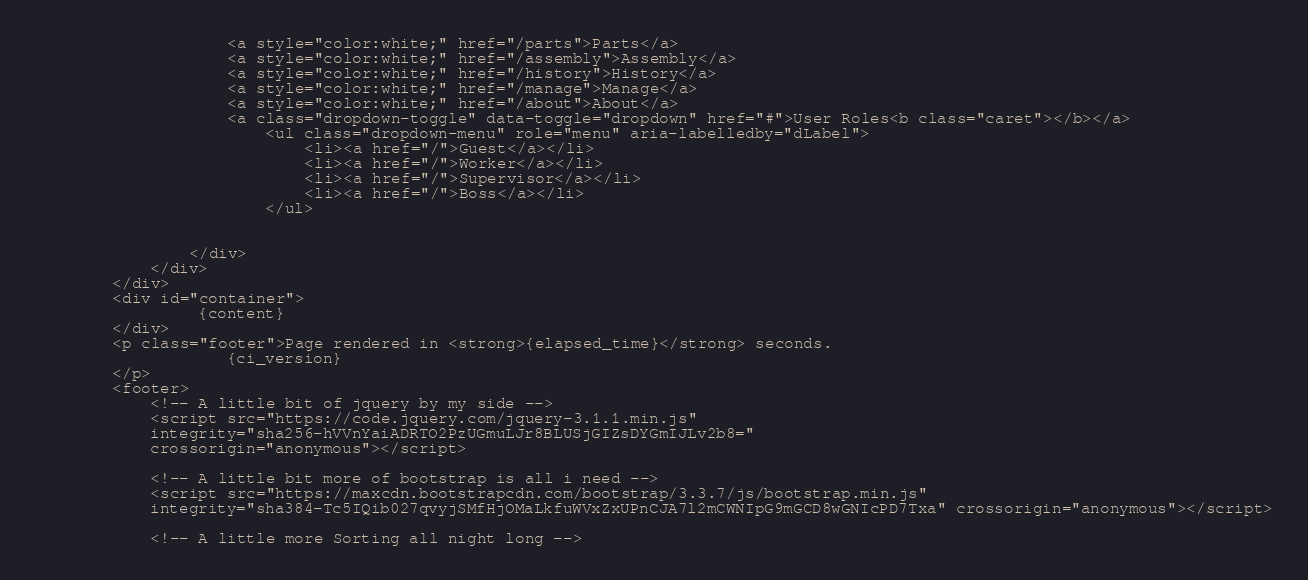<code> <loc_0><loc_0><loc_500><loc_500><_PHP_>					<a style="color:white;" href="/parts">Parts</a>
					<a style="color:white;" href="/assembly">Assembly</a>
					<a style="color:white;" href="/history">History</a>					
					<a style="color:white;" href="/manage">Manage</a>
					<a style="color:white;" href="/about">About</a> 
					<a class="dropdown-toggle" data-toggle="dropdown" href="#">User Roles<b class="caret"></b></a>
						<ul class="dropdown-menu" role="menu" aria-labelledby="dLabel">
							<li><a href="/">Guest</a></li>
							<li><a href="/">Worker</a></li>
							<li><a href="/">Supervisor</a></li>
							<li><a href="/">Boss</a></li>
						</ul>
					

				</div>
            </div>    
		</div>
		<div id="container">
				 {content}
		</div>  
		<p class="footer">Page rendered in <strong>{elapsed_time}</strong> seconds. 
					{ci_version}
		</p>     
		<footer>
			<!-- A little bit of jquery by my side --> 
			<script src="https://code.jquery.com/jquery-3.1.1.min.js" 
			integrity="sha256-hVVnYaiADRTO2PzUGmuLJr8BLUSjGIZsDYGmIJLv2b8="
			crossorigin="anonymous"></script>

			<!-- A little bit more of bootstrap is all i need -->
			<script src="https://maxcdn.bootstrapcdn.com/bootstrap/3.3.7/js/bootstrap.min.js" 
			integrity="sha384-Tc5IQib027qvyjSMfHjOMaLkfuWVxZxUPnCJA7l2mCWNIpG9mGCD8wGNIcPD7Txa" crossorigin="anonymous"></script>

			<!-- A little more Sorting all night long --> </code> 